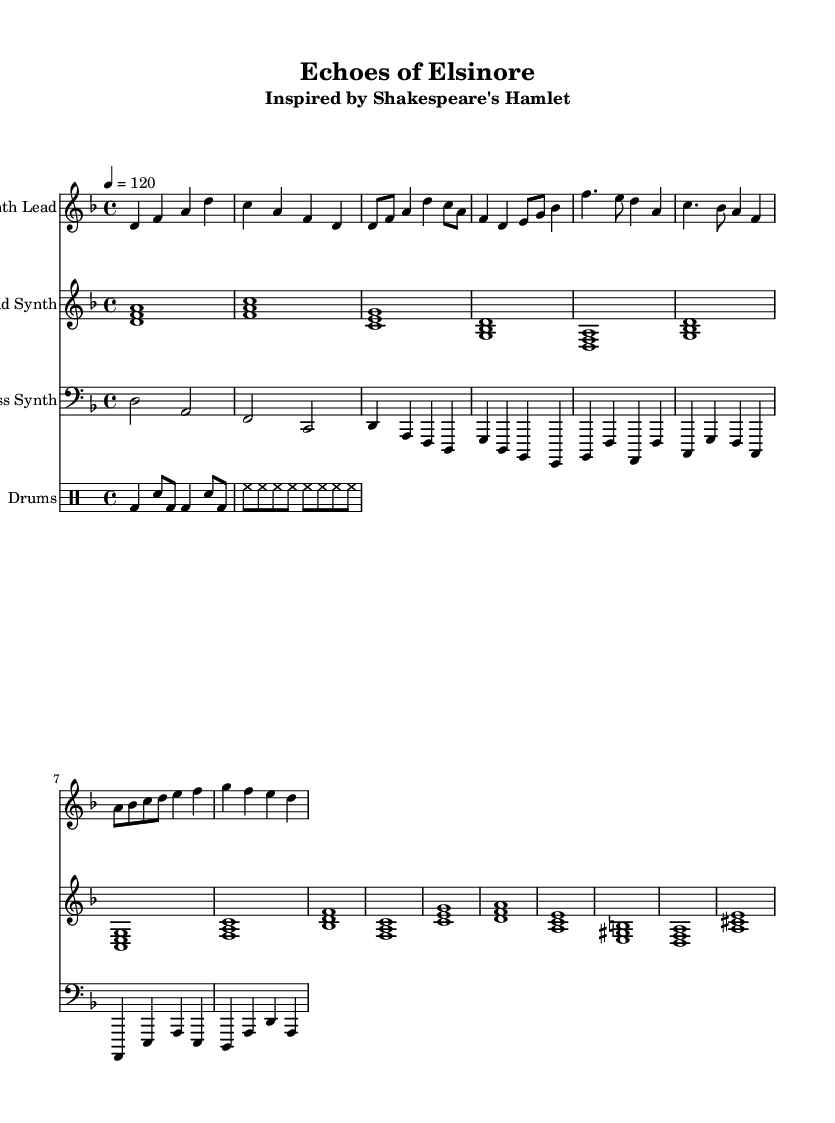What is the key signature of this music? The key signature indicated in the global section is D minor, which has one flat (B flat).
Answer: D minor What is the time signature of the piece? The time signature is 4/4, which means there are four beats in a measure and the quarter note gets one beat.
Answer: 4/4 What is the tempo marking for this composition? The tempo marking states that the piece should be played at a speed of 120 beats per minute.
Answer: 120 What instrument plays the synth lead? The instrument labeled as "Synth Lead" uses the treble clef and plays the melody, indicating it is likely played by a synthesizer.
Answer: Synth Lead How many measures does the pad synth have in the provided section? The pad synth has a total of 16 measures, as indicated by the rhythm and the repeated patterns observed in the notation.
Answer: 16 What is the main function of the bass synth in this composition? The bass synth provides the harmonic foundation and supports the overall sound, primarily playing lower frequencies.
Answer: Harmonic foundation What type of rhythm pattern is primarily used in the drum section? The drum section features a typical four-on-the-floor rhythm, which is common in electronic music, characterized by a bass drum hit on each beat.
Answer: Four-on-the-floor 